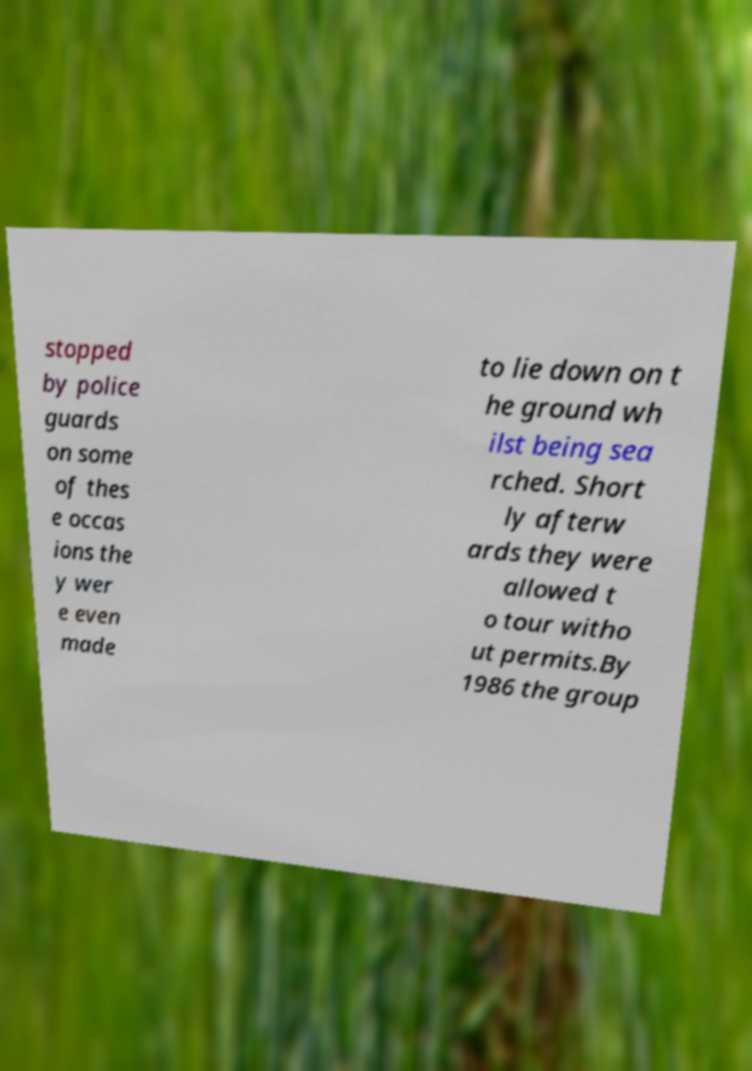Could you extract and type out the text from this image? stopped by police guards on some of thes e occas ions the y wer e even made to lie down on t he ground wh ilst being sea rched. Short ly afterw ards they were allowed t o tour witho ut permits.By 1986 the group 